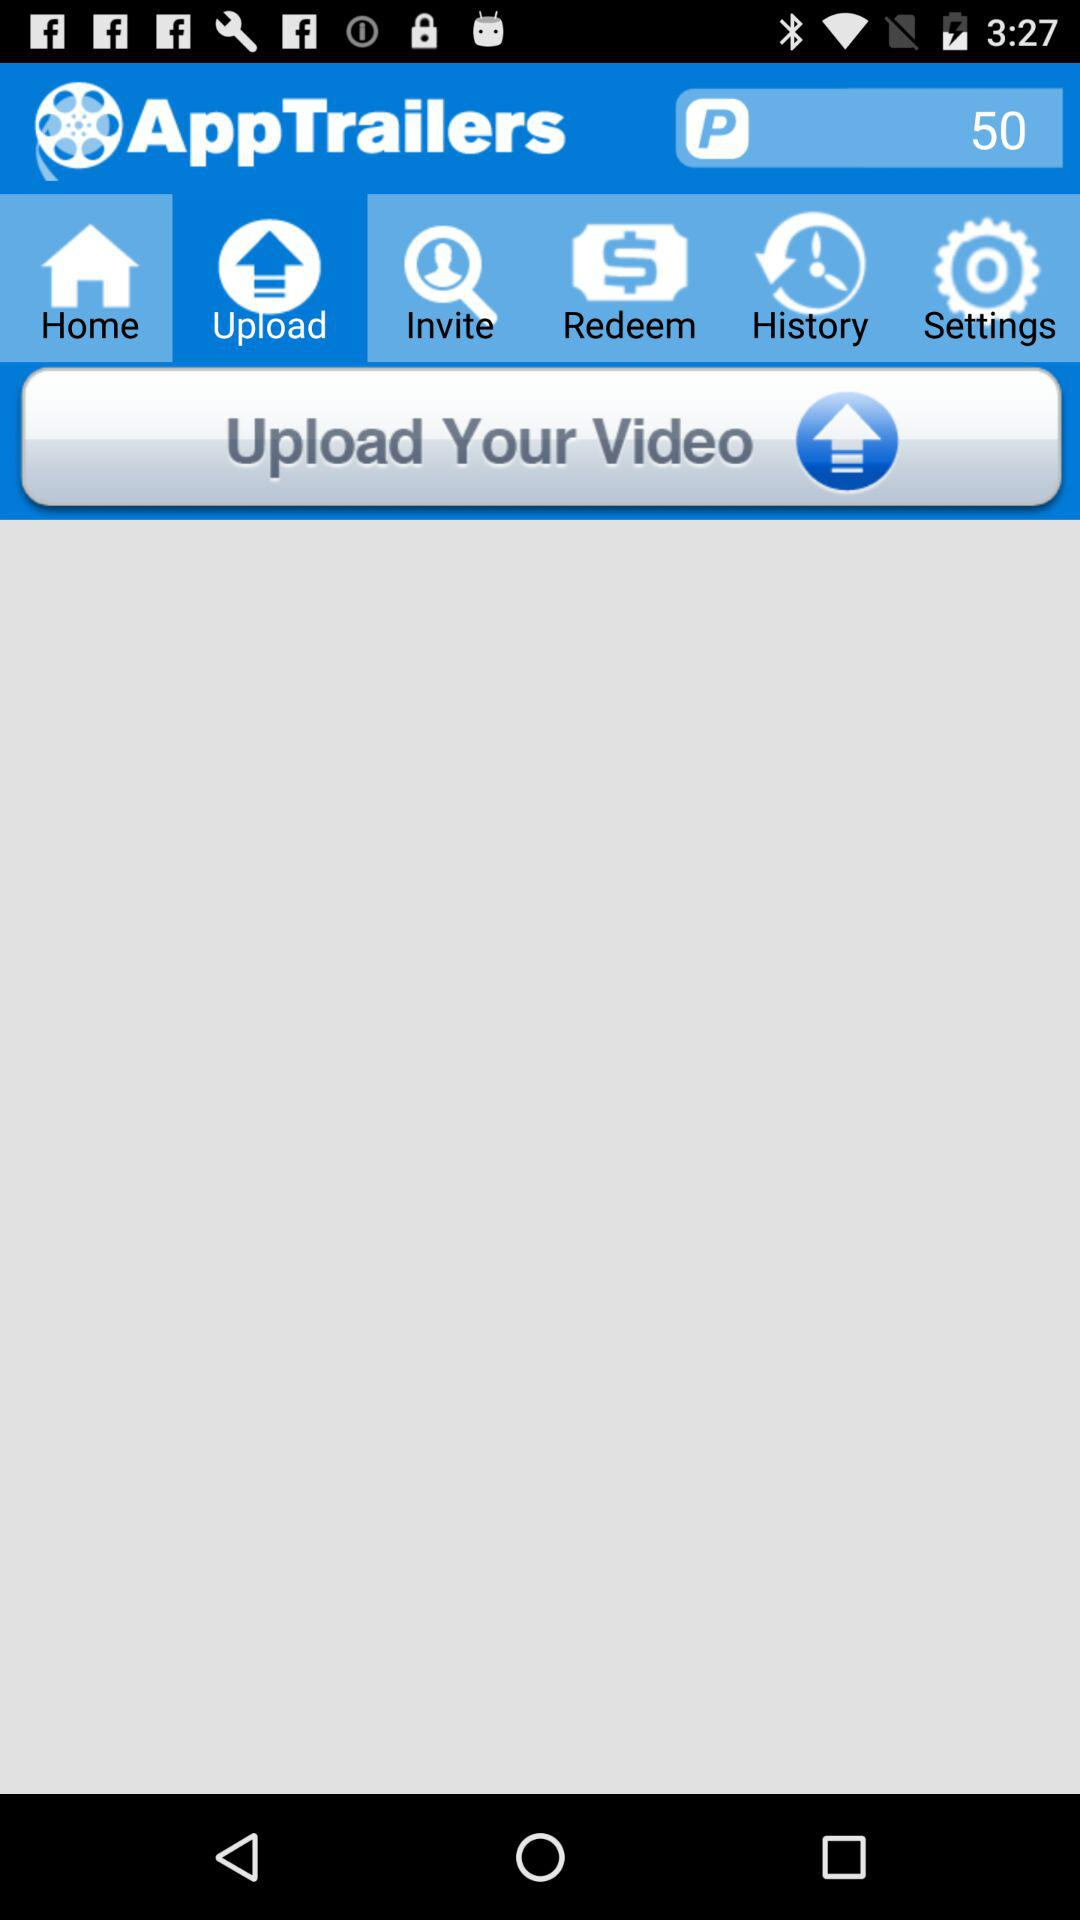How many points are displayed on the screen? There are 50 points displayed on the screen. 